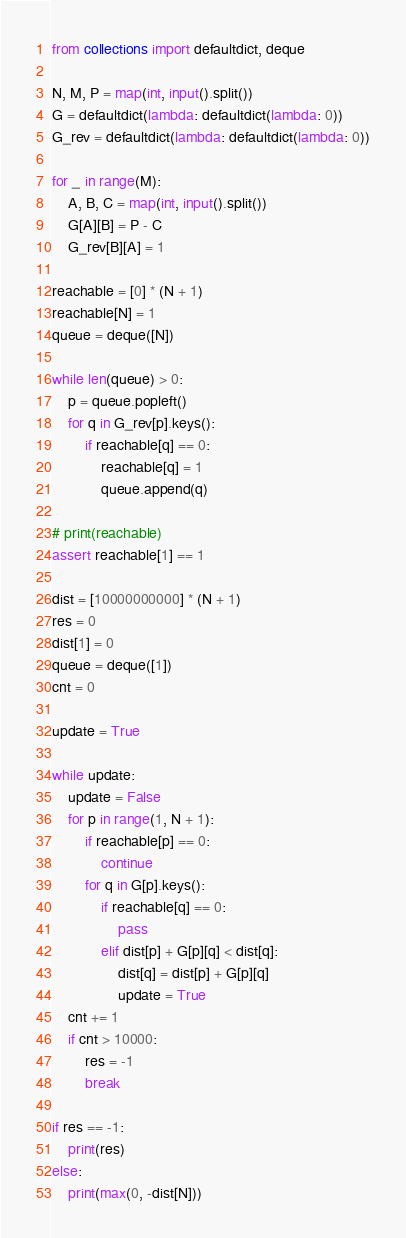Convert code to text. <code><loc_0><loc_0><loc_500><loc_500><_Python_>from collections import defaultdict, deque

N, M, P = map(int, input().split())
G = defaultdict(lambda: defaultdict(lambda: 0))
G_rev = defaultdict(lambda: defaultdict(lambda: 0))

for _ in range(M):
    A, B, C = map(int, input().split())
    G[A][B] = P - C
    G_rev[B][A] = 1

reachable = [0] * (N + 1)
reachable[N] = 1
queue = deque([N])

while len(queue) > 0:
    p = queue.popleft()
    for q in G_rev[p].keys():
        if reachable[q] == 0:
            reachable[q] = 1
            queue.append(q)

# print(reachable)
assert reachable[1] == 1

dist = [10000000000] * (N + 1)
res = 0
dist[1] = 0
queue = deque([1])
cnt = 0

update = True

while update:
    update = False
    for p in range(1, N + 1):
        if reachable[p] == 0:
            continue
        for q in G[p].keys():
            if reachable[q] == 0:
                pass
            elif dist[p] + G[p][q] < dist[q]:
                dist[q] = dist[p] + G[p][q]
                update = True
    cnt += 1
    if cnt > 10000:
        res = -1
        break
        
if res == -1:
    print(res)
else:
    print(max(0, -dist[N]))
</code> 